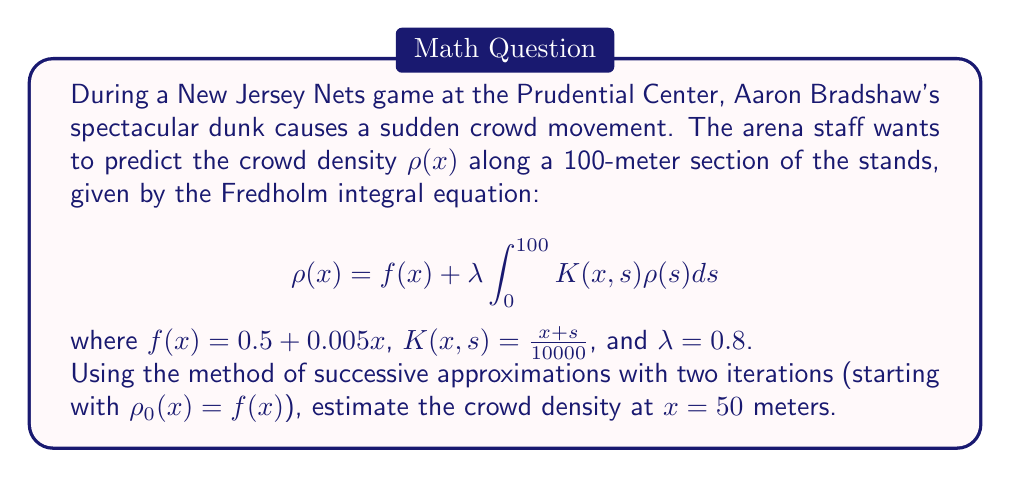Show me your answer to this math problem. Let's solve this step-by-step using the method of successive approximations:

1) We start with $\rho_0(x) = f(x) = 0.5 + 0.005x$

2) For the first iteration:
   $$\rho_1(x) = f(x) + \lambda \int_0^{100} K(x,s)\rho_0(s)ds$$
   $$= (0.5 + 0.005x) + 0.8 \int_0^{100} \frac{x+s}{10000}(0.5 + 0.005s)ds$$

3) Let's solve the integral:
   $$\int_0^{100} \frac{x+s}{10000}(0.5 + 0.005s)ds = \frac{x}{10000}\int_0^{100}(0.5 + 0.005s)ds + \frac{1}{10000}\int_0^{100}s(0.5 + 0.005s)ds$$
   $$= \frac{x}{10000}[50 + 25] + \frac{1}{10000}[\frac{50^2}{2} + \frac{0.005 \cdot 100^3}{3}] = \frac{75x}{10000} + \frac{2916.67}{10000}$$

4) Substituting back:
   $$\rho_1(x) = (0.5 + 0.005x) + 0.8(\frac{75x}{10000} + \frac{2916.67}{10000})$$
   $$= 0.5 + 0.005x + 0.006x + 0.233334 = 0.733334 + 0.011x$$

5) For the second iteration:
   $$\rho_2(x) = f(x) + \lambda \int_0^{100} K(x,s)\rho_1(s)ds$$
   $$= (0.5 + 0.005x) + 0.8 \int_0^{100} \frac{x+s}{10000}(0.733334 + 0.011s)ds$$

6) Solving the new integral:
   $$\int_0^{100} \frac{x+s}{10000}(0.733334 + 0.011s)ds = \frac{x}{10000}\int_0^{100}(0.733334 + 0.011s)ds + \frac{1}{10000}\int_0^{100}s(0.733334 + 0.011s)ds$$
   $$= \frac{x}{10000}[73.3334 + 55] + \frac{1}{10000}[\frac{73.3334 \cdot 100^2}{2} + \frac{0.011 \cdot 100^3}{3}] = \frac{128.3334x}{10000} + \frac{4033.334}{10000}$$

7) Substituting back:
   $$\rho_2(x) = (0.5 + 0.005x) + 0.8(\frac{128.3334x}{10000} + \frac{4033.334}{10000})$$
   $$= 0.5 + 0.005x + 0.0102667x + 0.322667 = 0.822667 + 0.0152667x$$

8) Now, we can estimate the crowd density at $x = 50$ meters:
   $$\rho_2(50) = 0.822667 + 0.0152667 \cdot 50 = 1.586$$
Answer: 1.586 people per meter 